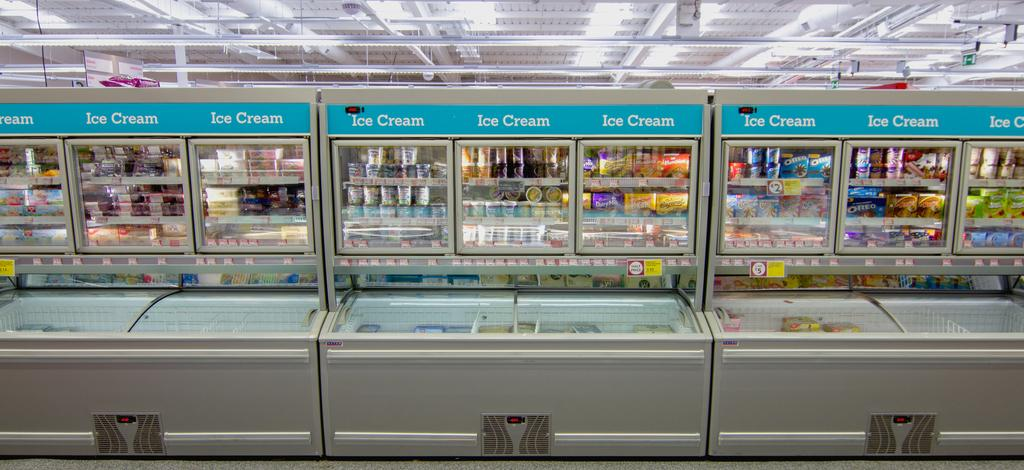<image>
Offer a succinct explanation of the picture presented. A row of freezer compartments in a supermarket are labeled with the words Ice Cream. 